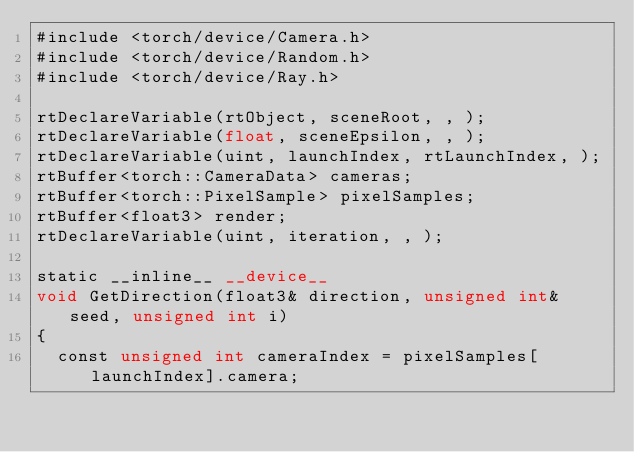Convert code to text. <code><loc_0><loc_0><loc_500><loc_500><_Cuda_>#include <torch/device/Camera.h>
#include <torch/device/Random.h>
#include <torch/device/Ray.h>

rtDeclareVariable(rtObject, sceneRoot, , );
rtDeclareVariable(float, sceneEpsilon, , );
rtDeclareVariable(uint, launchIndex, rtLaunchIndex, );
rtBuffer<torch::CameraData> cameras;
rtBuffer<torch::PixelSample> pixelSamples;
rtBuffer<float3> render;
rtDeclareVariable(uint, iteration, , );

static __inline__ __device__
void GetDirection(float3& direction, unsigned int& seed, unsigned int i)
{
  const unsigned int cameraIndex = pixelSamples[launchIndex].camera;</code> 